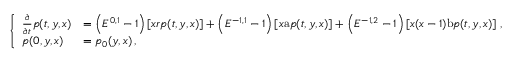<formula> <loc_0><loc_0><loc_500><loc_500>\left \{ \begin{array} { l l } { \frac { \partial } { \partial t } p ( t , y , x ) } & { = \left ( E ^ { 0 , 1 } - 1 \right ) \left [ x r p ( t , y , x ) \right ] + \left ( E ^ { - 1 , 1 } - 1 \right ) \left [ x a p ( t , y , x ) \right ] + \left ( E ^ { - 1 , 2 } - 1 \right ) \left [ x ( x - 1 ) b p ( t , y , x ) \right ] \, , } \\ { p ( 0 , y , x ) } & { = p _ { 0 } ( y , x ) \, , } \end{array}</formula> 